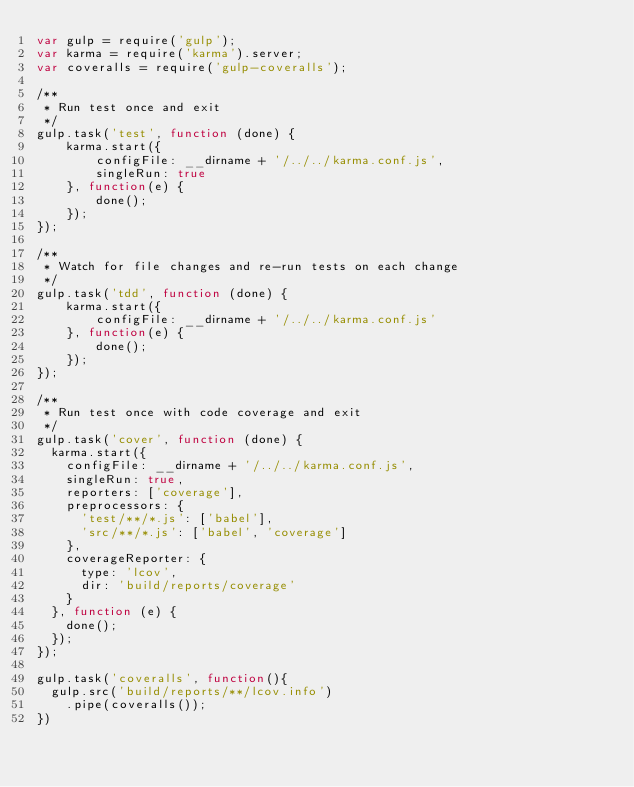<code> <loc_0><loc_0><loc_500><loc_500><_JavaScript_>var gulp = require('gulp');
var karma = require('karma').server;
var coveralls = require('gulp-coveralls');

/**
 * Run test once and exit
 */
gulp.task('test', function (done) {
    karma.start({
        configFile: __dirname + '/../../karma.conf.js',
        singleRun: true
    }, function(e) {
        done();
    });
});

/**
 * Watch for file changes and re-run tests on each change
 */
gulp.task('tdd', function (done) {
    karma.start({
        configFile: __dirname + '/../../karma.conf.js'
    }, function(e) {
        done();
    });
});

/**
 * Run test once with code coverage and exit
 */
gulp.task('cover', function (done) {
  karma.start({
    configFile: __dirname + '/../../karma.conf.js',
    singleRun: true,
    reporters: ['coverage'],
    preprocessors: {
      'test/**/*.js': ['babel'],
      'src/**/*.js': ['babel', 'coverage']
    },
    coverageReporter: {
      type: 'lcov',
      dir: 'build/reports/coverage'
    }
  }, function (e) {
    done();
  });
});

gulp.task('coveralls', function(){
  gulp.src('build/reports/**/lcov.info')
    .pipe(coveralls());
})
</code> 